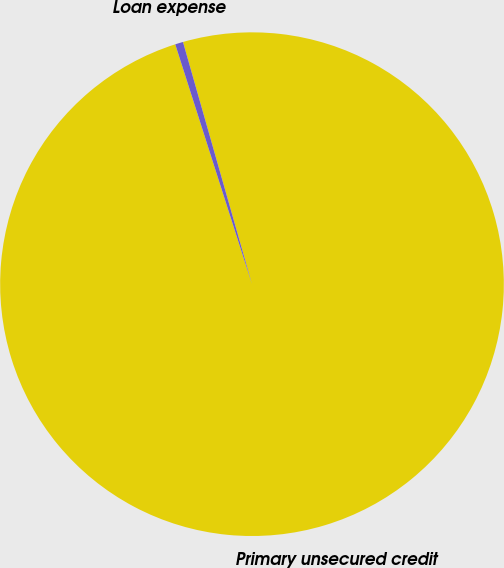<chart> <loc_0><loc_0><loc_500><loc_500><pie_chart><fcel>Primary unsecured credit<fcel>Loan expense<nl><fcel>99.49%<fcel>0.51%<nl></chart> 